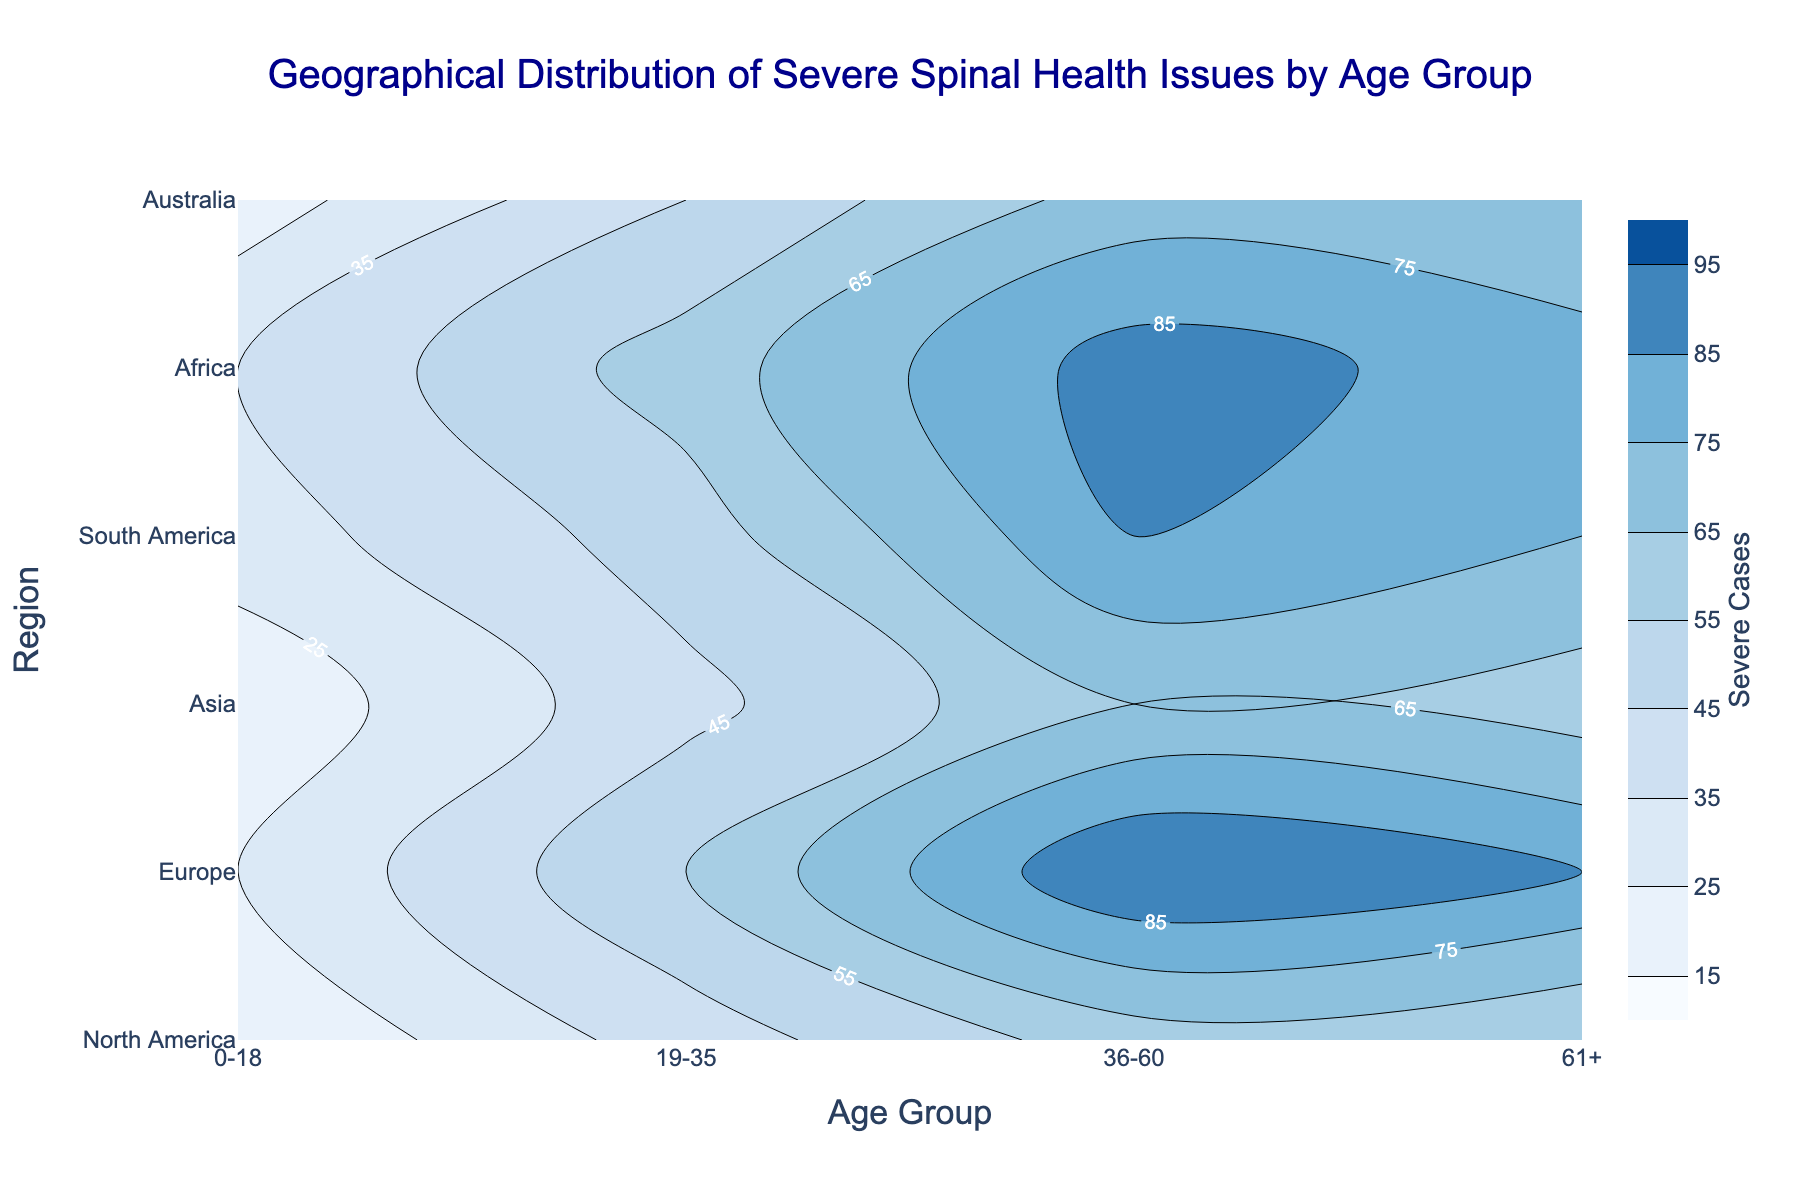What's the title of the plot? The title of the plot is written at the top center and is often larger and bolder than other text.
Answer: Geographical Distribution of Severe Spinal Health Issues by Age Group What are the labels on the x-axis? The x-axis labels usually represent the age groups which are seen at the bottom of the figure.
Answer: Age Group Which region shows the highest number of severe cases in the 36-60 age group? By looking at the color scale and matching the darkest contour, we can identify which region has the highest count.
Answer: Asia How many regions are represented in the plot? The y-axis lists all the regions, and counting them gives the total number of regions.
Answer: 6 Compare the severe case counts for Europe and Africa in the 61+ age group. Which has more cases? By locating the 61+ age group on the x-axis and tracing vertically to Europe and Africa rows, we compare the contour levels or numerical values.
Answer: Europe Which age group in South America has the least severe spinal health issues? By reviewing the colors for each age group in South America, the lightest color indicates the least severe cases.
Answer: 0-18 What is the general trend of severe spinal health issues with age in North America? By following the color gradient for North America along the age groups, we can infer the trend.
Answer: Increase until 36-60, then slightly decrease Sort the regions in descending order of severe cases for the 61+ age group. By comparing the contour levels or colors for the 61+ age group across all regions, we can list them from highest to lowest.
Answer: Asia, North America, Europe, South America, Australia, Africa 